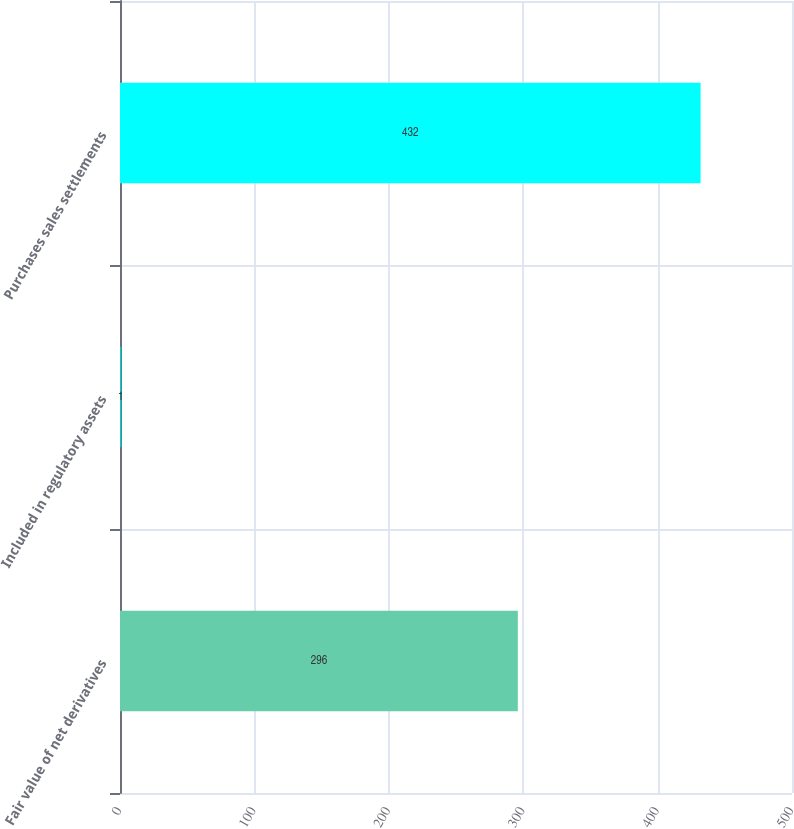Convert chart to OTSL. <chart><loc_0><loc_0><loc_500><loc_500><bar_chart><fcel>Fair value of net derivatives<fcel>Included in regulatory assets<fcel>Purchases sales settlements<nl><fcel>296<fcel>1<fcel>432<nl></chart> 